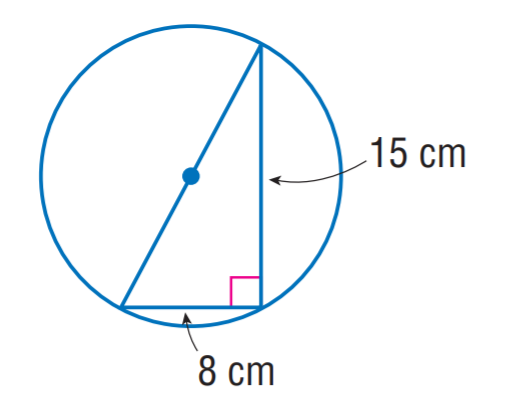Answer the mathemtical geometry problem and directly provide the correct option letter.
Question: The triangle is inscribed into the circle. Find the exact circumference of the circle.
Choices: A: 16 \pi B: 17 \pi C: 32 \pi D: 34 \pi B 